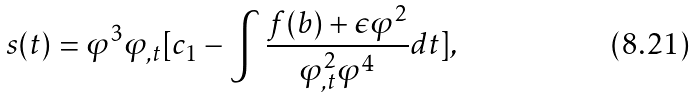<formula> <loc_0><loc_0><loc_500><loc_500>s ( t ) = \varphi ^ { 3 } \varphi _ { , t } [ c _ { 1 } - \int { \frac { f ( b ) + \epsilon \varphi ^ { 2 } } { \varphi _ { , t } ^ { 2 } \varphi ^ { 4 } } d t } ] ,</formula> 